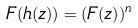<formula> <loc_0><loc_0><loc_500><loc_500>F ( h ( z ) ) = ( F ( z ) ) ^ { n }</formula> 